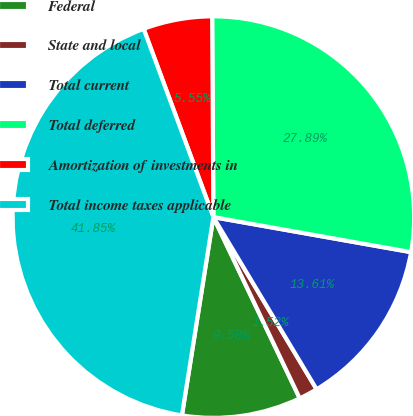Convert chart to OTSL. <chart><loc_0><loc_0><loc_500><loc_500><pie_chart><fcel>Federal<fcel>State and local<fcel>Total current<fcel>Total deferred<fcel>Amortization of investments in<fcel>Total income taxes applicable<nl><fcel>9.58%<fcel>1.52%<fcel>13.61%<fcel>27.89%<fcel>5.55%<fcel>41.85%<nl></chart> 